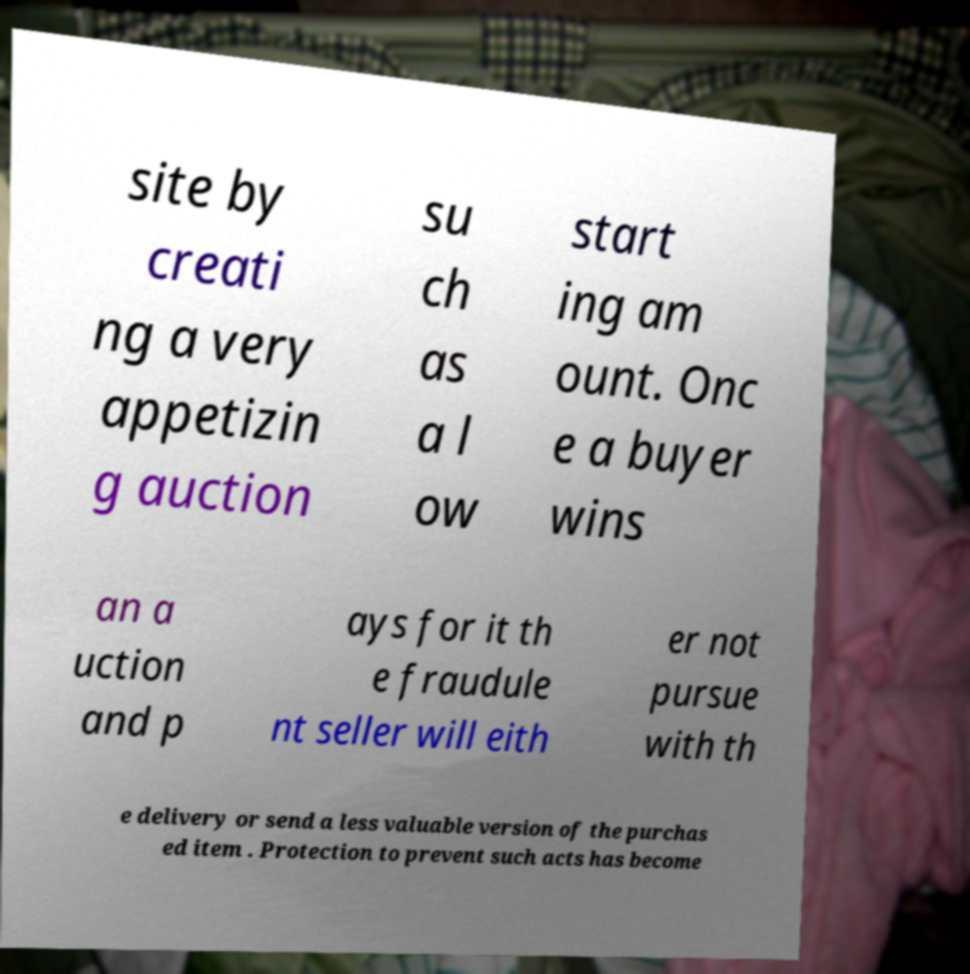For documentation purposes, I need the text within this image transcribed. Could you provide that? site by creati ng a very appetizin g auction su ch as a l ow start ing am ount. Onc e a buyer wins an a uction and p ays for it th e fraudule nt seller will eith er not pursue with th e delivery or send a less valuable version of the purchas ed item . Protection to prevent such acts has become 